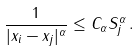<formula> <loc_0><loc_0><loc_500><loc_500>\frac { 1 } { | x _ { i } - x _ { j } | ^ { \alpha } } \leq C _ { \alpha } S _ { j } ^ { \alpha } \, .</formula> 